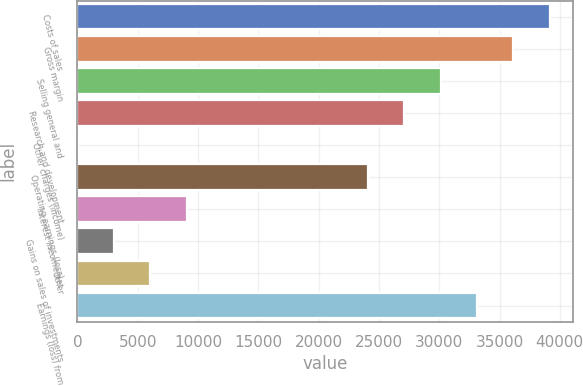Convert chart to OTSL. <chart><loc_0><loc_0><loc_500><loc_500><bar_chart><fcel>Costs of sales<fcel>Gross margin<fcel>Selling general and<fcel>Research and development<fcel>Other charges (income)<fcel>Operating earnings (loss)<fcel>Interest income net<fcel>Gains on sales of investments<fcel>Other<fcel>Earnings (loss) from<nl><fcel>39148.5<fcel>36139<fcel>30120<fcel>27110.5<fcel>25<fcel>24101<fcel>9053.5<fcel>3034.5<fcel>6044<fcel>33129.5<nl></chart> 